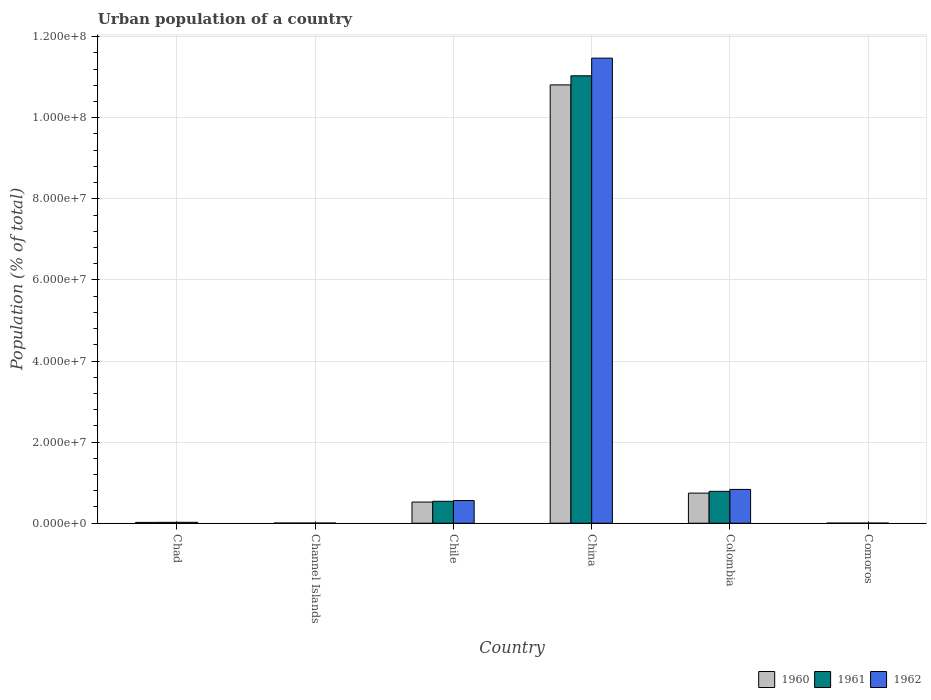How many groups of bars are there?
Ensure brevity in your answer.  6. Are the number of bars per tick equal to the number of legend labels?
Give a very brief answer. Yes. In how many cases, is the number of bars for a given country not equal to the number of legend labels?
Offer a very short reply. 0. What is the urban population in 1962 in China?
Give a very brief answer. 1.15e+08. Across all countries, what is the maximum urban population in 1962?
Make the answer very short. 1.15e+08. Across all countries, what is the minimum urban population in 1960?
Your response must be concise. 2.37e+04. In which country was the urban population in 1961 maximum?
Provide a succinct answer. China. In which country was the urban population in 1960 minimum?
Provide a succinct answer. Comoros. What is the total urban population in 1962 in the graph?
Offer a terse response. 1.29e+08. What is the difference between the urban population in 1962 in Chad and that in Comoros?
Offer a very short reply. 1.98e+05. What is the difference between the urban population in 1960 in Colombia and the urban population in 1962 in Comoros?
Your answer should be compact. 7.39e+06. What is the average urban population in 1962 per country?
Provide a short and direct response. 2.15e+07. What is the difference between the urban population of/in 1961 and urban population of/in 1960 in Chile?
Make the answer very short. 1.85e+05. In how many countries, is the urban population in 1961 greater than 12000000 %?
Your response must be concise. 1. What is the ratio of the urban population in 1961 in Channel Islands to that in China?
Keep it short and to the point. 0. Is the difference between the urban population in 1961 in Channel Islands and Comoros greater than the difference between the urban population in 1960 in Channel Islands and Comoros?
Keep it short and to the point. No. What is the difference between the highest and the second highest urban population in 1960?
Your answer should be compact. 1.03e+08. What is the difference between the highest and the lowest urban population in 1960?
Offer a terse response. 1.08e+08. In how many countries, is the urban population in 1962 greater than the average urban population in 1962 taken over all countries?
Provide a succinct answer. 1. What does the 2nd bar from the left in Channel Islands represents?
Keep it short and to the point. 1961. What does the 1st bar from the right in Colombia represents?
Your response must be concise. 1962. Are the values on the major ticks of Y-axis written in scientific E-notation?
Your answer should be compact. Yes. Does the graph contain grids?
Provide a succinct answer. Yes. How are the legend labels stacked?
Ensure brevity in your answer.  Horizontal. What is the title of the graph?
Ensure brevity in your answer.  Urban population of a country. Does "2010" appear as one of the legend labels in the graph?
Give a very brief answer. No. What is the label or title of the X-axis?
Offer a very short reply. Country. What is the label or title of the Y-axis?
Provide a short and direct response. Population (% of total). What is the Population (% of total) in 1960 in Chad?
Keep it short and to the point. 2.01e+05. What is the Population (% of total) in 1961 in Chad?
Offer a very short reply. 2.13e+05. What is the Population (% of total) of 1962 in Chad?
Keep it short and to the point. 2.26e+05. What is the Population (% of total) of 1960 in Channel Islands?
Your answer should be compact. 4.23e+04. What is the Population (% of total) in 1961 in Channel Islands?
Give a very brief answer. 4.24e+04. What is the Population (% of total) of 1962 in Channel Islands?
Your response must be concise. 4.25e+04. What is the Population (% of total) in 1960 in Chile?
Ensure brevity in your answer.  5.22e+06. What is the Population (% of total) of 1961 in Chile?
Make the answer very short. 5.41e+06. What is the Population (% of total) of 1962 in Chile?
Your response must be concise. 5.59e+06. What is the Population (% of total) of 1960 in China?
Keep it short and to the point. 1.08e+08. What is the Population (% of total) of 1961 in China?
Ensure brevity in your answer.  1.10e+08. What is the Population (% of total) of 1962 in China?
Offer a very short reply. 1.15e+08. What is the Population (% of total) in 1960 in Colombia?
Offer a terse response. 7.42e+06. What is the Population (% of total) of 1961 in Colombia?
Your response must be concise. 7.87e+06. What is the Population (% of total) in 1962 in Colombia?
Ensure brevity in your answer.  8.33e+06. What is the Population (% of total) of 1960 in Comoros?
Your answer should be compact. 2.37e+04. What is the Population (% of total) of 1961 in Comoros?
Keep it short and to the point. 2.56e+04. What is the Population (% of total) in 1962 in Comoros?
Your response must be concise. 2.77e+04. Across all countries, what is the maximum Population (% of total) in 1960?
Your answer should be compact. 1.08e+08. Across all countries, what is the maximum Population (% of total) of 1961?
Give a very brief answer. 1.10e+08. Across all countries, what is the maximum Population (% of total) of 1962?
Give a very brief answer. 1.15e+08. Across all countries, what is the minimum Population (% of total) in 1960?
Offer a very short reply. 2.37e+04. Across all countries, what is the minimum Population (% of total) of 1961?
Offer a terse response. 2.56e+04. Across all countries, what is the minimum Population (% of total) in 1962?
Make the answer very short. 2.77e+04. What is the total Population (% of total) in 1960 in the graph?
Offer a terse response. 1.21e+08. What is the total Population (% of total) in 1961 in the graph?
Your answer should be compact. 1.24e+08. What is the total Population (% of total) in 1962 in the graph?
Provide a succinct answer. 1.29e+08. What is the difference between the Population (% of total) in 1960 in Chad and that in Channel Islands?
Provide a succinct answer. 1.59e+05. What is the difference between the Population (% of total) of 1961 in Chad and that in Channel Islands?
Your response must be concise. 1.71e+05. What is the difference between the Population (% of total) in 1962 in Chad and that in Channel Islands?
Give a very brief answer. 1.83e+05. What is the difference between the Population (% of total) in 1960 in Chad and that in Chile?
Give a very brief answer. -5.02e+06. What is the difference between the Population (% of total) of 1961 in Chad and that in Chile?
Your response must be concise. -5.19e+06. What is the difference between the Population (% of total) of 1962 in Chad and that in Chile?
Your answer should be very brief. -5.37e+06. What is the difference between the Population (% of total) of 1960 in Chad and that in China?
Provide a succinct answer. -1.08e+08. What is the difference between the Population (% of total) in 1961 in Chad and that in China?
Provide a succinct answer. -1.10e+08. What is the difference between the Population (% of total) in 1962 in Chad and that in China?
Your response must be concise. -1.14e+08. What is the difference between the Population (% of total) in 1960 in Chad and that in Colombia?
Keep it short and to the point. -7.22e+06. What is the difference between the Population (% of total) of 1961 in Chad and that in Colombia?
Provide a short and direct response. -7.65e+06. What is the difference between the Population (% of total) in 1962 in Chad and that in Colombia?
Your answer should be compact. -8.11e+06. What is the difference between the Population (% of total) of 1960 in Chad and that in Comoros?
Provide a short and direct response. 1.77e+05. What is the difference between the Population (% of total) in 1961 in Chad and that in Comoros?
Your answer should be compact. 1.88e+05. What is the difference between the Population (% of total) in 1962 in Chad and that in Comoros?
Your answer should be very brief. 1.98e+05. What is the difference between the Population (% of total) in 1960 in Channel Islands and that in Chile?
Keep it short and to the point. -5.18e+06. What is the difference between the Population (% of total) of 1961 in Channel Islands and that in Chile?
Give a very brief answer. -5.36e+06. What is the difference between the Population (% of total) of 1962 in Channel Islands and that in Chile?
Offer a terse response. -5.55e+06. What is the difference between the Population (% of total) in 1960 in Channel Islands and that in China?
Make the answer very short. -1.08e+08. What is the difference between the Population (% of total) in 1961 in Channel Islands and that in China?
Offer a very short reply. -1.10e+08. What is the difference between the Population (% of total) in 1962 in Channel Islands and that in China?
Give a very brief answer. -1.15e+08. What is the difference between the Population (% of total) of 1960 in Channel Islands and that in Colombia?
Your answer should be very brief. -7.38e+06. What is the difference between the Population (% of total) in 1961 in Channel Islands and that in Colombia?
Give a very brief answer. -7.82e+06. What is the difference between the Population (% of total) in 1962 in Channel Islands and that in Colombia?
Keep it short and to the point. -8.29e+06. What is the difference between the Population (% of total) in 1960 in Channel Islands and that in Comoros?
Make the answer very short. 1.87e+04. What is the difference between the Population (% of total) of 1961 in Channel Islands and that in Comoros?
Offer a very short reply. 1.68e+04. What is the difference between the Population (% of total) in 1962 in Channel Islands and that in Comoros?
Give a very brief answer. 1.49e+04. What is the difference between the Population (% of total) of 1960 in Chile and that in China?
Offer a very short reply. -1.03e+08. What is the difference between the Population (% of total) of 1961 in Chile and that in China?
Keep it short and to the point. -1.05e+08. What is the difference between the Population (% of total) of 1962 in Chile and that in China?
Ensure brevity in your answer.  -1.09e+08. What is the difference between the Population (% of total) of 1960 in Chile and that in Colombia?
Give a very brief answer. -2.20e+06. What is the difference between the Population (% of total) of 1961 in Chile and that in Colombia?
Provide a short and direct response. -2.46e+06. What is the difference between the Population (% of total) of 1962 in Chile and that in Colombia?
Keep it short and to the point. -2.74e+06. What is the difference between the Population (% of total) of 1960 in Chile and that in Comoros?
Your answer should be very brief. 5.20e+06. What is the difference between the Population (% of total) in 1961 in Chile and that in Comoros?
Ensure brevity in your answer.  5.38e+06. What is the difference between the Population (% of total) of 1962 in Chile and that in Comoros?
Make the answer very short. 5.56e+06. What is the difference between the Population (% of total) in 1960 in China and that in Colombia?
Provide a short and direct response. 1.01e+08. What is the difference between the Population (% of total) of 1961 in China and that in Colombia?
Ensure brevity in your answer.  1.02e+08. What is the difference between the Population (% of total) of 1962 in China and that in Colombia?
Offer a terse response. 1.06e+08. What is the difference between the Population (% of total) in 1960 in China and that in Comoros?
Offer a terse response. 1.08e+08. What is the difference between the Population (% of total) in 1961 in China and that in Comoros?
Provide a short and direct response. 1.10e+08. What is the difference between the Population (% of total) in 1962 in China and that in Comoros?
Provide a succinct answer. 1.15e+08. What is the difference between the Population (% of total) in 1960 in Colombia and that in Comoros?
Your response must be concise. 7.40e+06. What is the difference between the Population (% of total) in 1961 in Colombia and that in Comoros?
Offer a very short reply. 7.84e+06. What is the difference between the Population (% of total) of 1962 in Colombia and that in Comoros?
Ensure brevity in your answer.  8.31e+06. What is the difference between the Population (% of total) in 1960 in Chad and the Population (% of total) in 1961 in Channel Islands?
Offer a very short reply. 1.59e+05. What is the difference between the Population (% of total) in 1960 in Chad and the Population (% of total) in 1962 in Channel Islands?
Offer a very short reply. 1.58e+05. What is the difference between the Population (% of total) in 1961 in Chad and the Population (% of total) in 1962 in Channel Islands?
Provide a succinct answer. 1.71e+05. What is the difference between the Population (% of total) in 1960 in Chad and the Population (% of total) in 1961 in Chile?
Keep it short and to the point. -5.20e+06. What is the difference between the Population (% of total) of 1960 in Chad and the Population (% of total) of 1962 in Chile?
Make the answer very short. -5.39e+06. What is the difference between the Population (% of total) of 1961 in Chad and the Population (% of total) of 1962 in Chile?
Provide a short and direct response. -5.38e+06. What is the difference between the Population (% of total) of 1960 in Chad and the Population (% of total) of 1961 in China?
Provide a short and direct response. -1.10e+08. What is the difference between the Population (% of total) in 1960 in Chad and the Population (% of total) in 1962 in China?
Provide a short and direct response. -1.14e+08. What is the difference between the Population (% of total) in 1961 in Chad and the Population (% of total) in 1962 in China?
Provide a short and direct response. -1.14e+08. What is the difference between the Population (% of total) of 1960 in Chad and the Population (% of total) of 1961 in Colombia?
Ensure brevity in your answer.  -7.67e+06. What is the difference between the Population (% of total) in 1960 in Chad and the Population (% of total) in 1962 in Colombia?
Your answer should be compact. -8.13e+06. What is the difference between the Population (% of total) in 1961 in Chad and the Population (% of total) in 1962 in Colombia?
Keep it short and to the point. -8.12e+06. What is the difference between the Population (% of total) of 1960 in Chad and the Population (% of total) of 1961 in Comoros?
Give a very brief answer. 1.75e+05. What is the difference between the Population (% of total) in 1960 in Chad and the Population (% of total) in 1962 in Comoros?
Ensure brevity in your answer.  1.73e+05. What is the difference between the Population (% of total) of 1961 in Chad and the Population (% of total) of 1962 in Comoros?
Ensure brevity in your answer.  1.85e+05. What is the difference between the Population (% of total) of 1960 in Channel Islands and the Population (% of total) of 1961 in Chile?
Ensure brevity in your answer.  -5.36e+06. What is the difference between the Population (% of total) of 1960 in Channel Islands and the Population (% of total) of 1962 in Chile?
Give a very brief answer. -5.55e+06. What is the difference between the Population (% of total) of 1961 in Channel Islands and the Population (% of total) of 1962 in Chile?
Offer a very short reply. -5.55e+06. What is the difference between the Population (% of total) of 1960 in Channel Islands and the Population (% of total) of 1961 in China?
Your response must be concise. -1.10e+08. What is the difference between the Population (% of total) in 1960 in Channel Islands and the Population (% of total) in 1962 in China?
Your response must be concise. -1.15e+08. What is the difference between the Population (% of total) in 1961 in Channel Islands and the Population (% of total) in 1962 in China?
Offer a very short reply. -1.15e+08. What is the difference between the Population (% of total) of 1960 in Channel Islands and the Population (% of total) of 1961 in Colombia?
Make the answer very short. -7.83e+06. What is the difference between the Population (% of total) of 1960 in Channel Islands and the Population (% of total) of 1962 in Colombia?
Offer a terse response. -8.29e+06. What is the difference between the Population (% of total) in 1961 in Channel Islands and the Population (% of total) in 1962 in Colombia?
Provide a short and direct response. -8.29e+06. What is the difference between the Population (% of total) of 1960 in Channel Islands and the Population (% of total) of 1961 in Comoros?
Make the answer very short. 1.67e+04. What is the difference between the Population (% of total) in 1960 in Channel Islands and the Population (% of total) in 1962 in Comoros?
Give a very brief answer. 1.47e+04. What is the difference between the Population (% of total) in 1961 in Channel Islands and the Population (% of total) in 1962 in Comoros?
Your answer should be compact. 1.48e+04. What is the difference between the Population (% of total) of 1960 in Chile and the Population (% of total) of 1961 in China?
Your answer should be compact. -1.05e+08. What is the difference between the Population (% of total) of 1960 in Chile and the Population (% of total) of 1962 in China?
Your answer should be compact. -1.09e+08. What is the difference between the Population (% of total) of 1961 in Chile and the Population (% of total) of 1962 in China?
Offer a very short reply. -1.09e+08. What is the difference between the Population (% of total) in 1960 in Chile and the Population (% of total) in 1961 in Colombia?
Offer a terse response. -2.65e+06. What is the difference between the Population (% of total) in 1960 in Chile and the Population (% of total) in 1962 in Colombia?
Offer a very short reply. -3.11e+06. What is the difference between the Population (% of total) in 1961 in Chile and the Population (% of total) in 1962 in Colombia?
Your answer should be very brief. -2.93e+06. What is the difference between the Population (% of total) of 1960 in Chile and the Population (% of total) of 1961 in Comoros?
Offer a very short reply. 5.19e+06. What is the difference between the Population (% of total) of 1960 in Chile and the Population (% of total) of 1962 in Comoros?
Keep it short and to the point. 5.19e+06. What is the difference between the Population (% of total) of 1961 in Chile and the Population (% of total) of 1962 in Comoros?
Your response must be concise. 5.38e+06. What is the difference between the Population (% of total) in 1960 in China and the Population (% of total) in 1961 in Colombia?
Make the answer very short. 1.00e+08. What is the difference between the Population (% of total) of 1960 in China and the Population (% of total) of 1962 in Colombia?
Offer a very short reply. 9.98e+07. What is the difference between the Population (% of total) of 1961 in China and the Population (% of total) of 1962 in Colombia?
Provide a short and direct response. 1.02e+08. What is the difference between the Population (% of total) in 1960 in China and the Population (% of total) in 1961 in Comoros?
Make the answer very short. 1.08e+08. What is the difference between the Population (% of total) of 1960 in China and the Population (% of total) of 1962 in Comoros?
Give a very brief answer. 1.08e+08. What is the difference between the Population (% of total) of 1961 in China and the Population (% of total) of 1962 in Comoros?
Offer a very short reply. 1.10e+08. What is the difference between the Population (% of total) of 1960 in Colombia and the Population (% of total) of 1961 in Comoros?
Offer a terse response. 7.40e+06. What is the difference between the Population (% of total) of 1960 in Colombia and the Population (% of total) of 1962 in Comoros?
Offer a very short reply. 7.39e+06. What is the difference between the Population (% of total) of 1961 in Colombia and the Population (% of total) of 1962 in Comoros?
Your response must be concise. 7.84e+06. What is the average Population (% of total) of 1960 per country?
Give a very brief answer. 2.02e+07. What is the average Population (% of total) in 1961 per country?
Keep it short and to the point. 2.06e+07. What is the average Population (% of total) of 1962 per country?
Provide a short and direct response. 2.15e+07. What is the difference between the Population (% of total) of 1960 and Population (% of total) of 1961 in Chad?
Provide a succinct answer. -1.21e+04. What is the difference between the Population (% of total) in 1960 and Population (% of total) in 1962 in Chad?
Your response must be concise. -2.50e+04. What is the difference between the Population (% of total) of 1961 and Population (% of total) of 1962 in Chad?
Give a very brief answer. -1.29e+04. What is the difference between the Population (% of total) in 1960 and Population (% of total) in 1961 in Channel Islands?
Provide a succinct answer. -88. What is the difference between the Population (% of total) in 1960 and Population (% of total) in 1962 in Channel Islands?
Make the answer very short. -203. What is the difference between the Population (% of total) in 1961 and Population (% of total) in 1962 in Channel Islands?
Make the answer very short. -115. What is the difference between the Population (% of total) in 1960 and Population (% of total) in 1961 in Chile?
Your response must be concise. -1.85e+05. What is the difference between the Population (% of total) in 1960 and Population (% of total) in 1962 in Chile?
Give a very brief answer. -3.72e+05. What is the difference between the Population (% of total) of 1961 and Population (% of total) of 1962 in Chile?
Your answer should be very brief. -1.86e+05. What is the difference between the Population (% of total) in 1960 and Population (% of total) in 1961 in China?
Your answer should be very brief. -2.24e+06. What is the difference between the Population (% of total) in 1960 and Population (% of total) in 1962 in China?
Your answer should be compact. -6.60e+06. What is the difference between the Population (% of total) in 1961 and Population (% of total) in 1962 in China?
Give a very brief answer. -4.36e+06. What is the difference between the Population (% of total) of 1960 and Population (% of total) of 1961 in Colombia?
Keep it short and to the point. -4.46e+05. What is the difference between the Population (% of total) of 1960 and Population (% of total) of 1962 in Colombia?
Ensure brevity in your answer.  -9.13e+05. What is the difference between the Population (% of total) in 1961 and Population (% of total) in 1962 in Colombia?
Offer a terse response. -4.68e+05. What is the difference between the Population (% of total) in 1960 and Population (% of total) in 1961 in Comoros?
Give a very brief answer. -1917. What is the difference between the Population (% of total) of 1960 and Population (% of total) of 1962 in Comoros?
Ensure brevity in your answer.  -3975. What is the difference between the Population (% of total) in 1961 and Population (% of total) in 1962 in Comoros?
Offer a very short reply. -2058. What is the ratio of the Population (% of total) of 1960 in Chad to that in Channel Islands?
Provide a succinct answer. 4.75. What is the ratio of the Population (% of total) in 1961 in Chad to that in Channel Islands?
Give a very brief answer. 5.02. What is the ratio of the Population (% of total) in 1962 in Chad to that in Channel Islands?
Keep it short and to the point. 5.31. What is the ratio of the Population (% of total) in 1960 in Chad to that in Chile?
Offer a terse response. 0.04. What is the ratio of the Population (% of total) in 1961 in Chad to that in Chile?
Your answer should be very brief. 0.04. What is the ratio of the Population (% of total) of 1962 in Chad to that in Chile?
Provide a short and direct response. 0.04. What is the ratio of the Population (% of total) in 1960 in Chad to that in China?
Offer a very short reply. 0. What is the ratio of the Population (% of total) of 1961 in Chad to that in China?
Offer a terse response. 0. What is the ratio of the Population (% of total) of 1962 in Chad to that in China?
Provide a succinct answer. 0. What is the ratio of the Population (% of total) of 1960 in Chad to that in Colombia?
Give a very brief answer. 0.03. What is the ratio of the Population (% of total) of 1961 in Chad to that in Colombia?
Give a very brief answer. 0.03. What is the ratio of the Population (% of total) of 1962 in Chad to that in Colombia?
Provide a short and direct response. 0.03. What is the ratio of the Population (% of total) in 1960 in Chad to that in Comoros?
Your response must be concise. 8.49. What is the ratio of the Population (% of total) of 1961 in Chad to that in Comoros?
Your answer should be very brief. 8.32. What is the ratio of the Population (% of total) of 1962 in Chad to that in Comoros?
Ensure brevity in your answer.  8.17. What is the ratio of the Population (% of total) of 1960 in Channel Islands to that in Chile?
Provide a succinct answer. 0.01. What is the ratio of the Population (% of total) of 1961 in Channel Islands to that in Chile?
Your answer should be very brief. 0.01. What is the ratio of the Population (% of total) of 1962 in Channel Islands to that in Chile?
Your response must be concise. 0.01. What is the ratio of the Population (% of total) in 1960 in Channel Islands to that in China?
Your answer should be compact. 0. What is the ratio of the Population (% of total) of 1961 in Channel Islands to that in China?
Keep it short and to the point. 0. What is the ratio of the Population (% of total) of 1960 in Channel Islands to that in Colombia?
Offer a very short reply. 0.01. What is the ratio of the Population (% of total) of 1961 in Channel Islands to that in Colombia?
Make the answer very short. 0.01. What is the ratio of the Population (% of total) of 1962 in Channel Islands to that in Colombia?
Give a very brief answer. 0.01. What is the ratio of the Population (% of total) of 1960 in Channel Islands to that in Comoros?
Offer a very short reply. 1.79. What is the ratio of the Population (% of total) of 1961 in Channel Islands to that in Comoros?
Ensure brevity in your answer.  1.66. What is the ratio of the Population (% of total) in 1962 in Channel Islands to that in Comoros?
Make the answer very short. 1.54. What is the ratio of the Population (% of total) of 1960 in Chile to that in China?
Provide a short and direct response. 0.05. What is the ratio of the Population (% of total) in 1961 in Chile to that in China?
Give a very brief answer. 0.05. What is the ratio of the Population (% of total) in 1962 in Chile to that in China?
Provide a short and direct response. 0.05. What is the ratio of the Population (% of total) of 1960 in Chile to that in Colombia?
Give a very brief answer. 0.7. What is the ratio of the Population (% of total) of 1961 in Chile to that in Colombia?
Ensure brevity in your answer.  0.69. What is the ratio of the Population (% of total) of 1962 in Chile to that in Colombia?
Your answer should be very brief. 0.67. What is the ratio of the Population (% of total) in 1960 in Chile to that in Comoros?
Offer a very short reply. 220.38. What is the ratio of the Population (% of total) of 1961 in Chile to that in Comoros?
Provide a succinct answer. 211.13. What is the ratio of the Population (% of total) of 1962 in Chile to that in Comoros?
Ensure brevity in your answer.  202.16. What is the ratio of the Population (% of total) of 1960 in China to that in Colombia?
Your answer should be very brief. 14.56. What is the ratio of the Population (% of total) of 1961 in China to that in Colombia?
Your answer should be compact. 14.02. What is the ratio of the Population (% of total) in 1962 in China to that in Colombia?
Your answer should be compact. 13.76. What is the ratio of the Population (% of total) of 1960 in China to that in Comoros?
Provide a short and direct response. 4562.87. What is the ratio of the Population (% of total) of 1961 in China to that in Comoros?
Your answer should be compact. 4308.84. What is the ratio of the Population (% of total) in 1962 in China to that in Comoros?
Offer a terse response. 4145.81. What is the ratio of the Population (% of total) in 1960 in Colombia to that in Comoros?
Offer a very short reply. 313.31. What is the ratio of the Population (% of total) in 1961 in Colombia to that in Comoros?
Your answer should be compact. 307.26. What is the ratio of the Population (% of total) in 1962 in Colombia to that in Comoros?
Your answer should be very brief. 301.3. What is the difference between the highest and the second highest Population (% of total) in 1960?
Make the answer very short. 1.01e+08. What is the difference between the highest and the second highest Population (% of total) of 1961?
Offer a very short reply. 1.02e+08. What is the difference between the highest and the second highest Population (% of total) of 1962?
Your answer should be very brief. 1.06e+08. What is the difference between the highest and the lowest Population (% of total) in 1960?
Provide a short and direct response. 1.08e+08. What is the difference between the highest and the lowest Population (% of total) in 1961?
Provide a short and direct response. 1.10e+08. What is the difference between the highest and the lowest Population (% of total) of 1962?
Offer a terse response. 1.15e+08. 